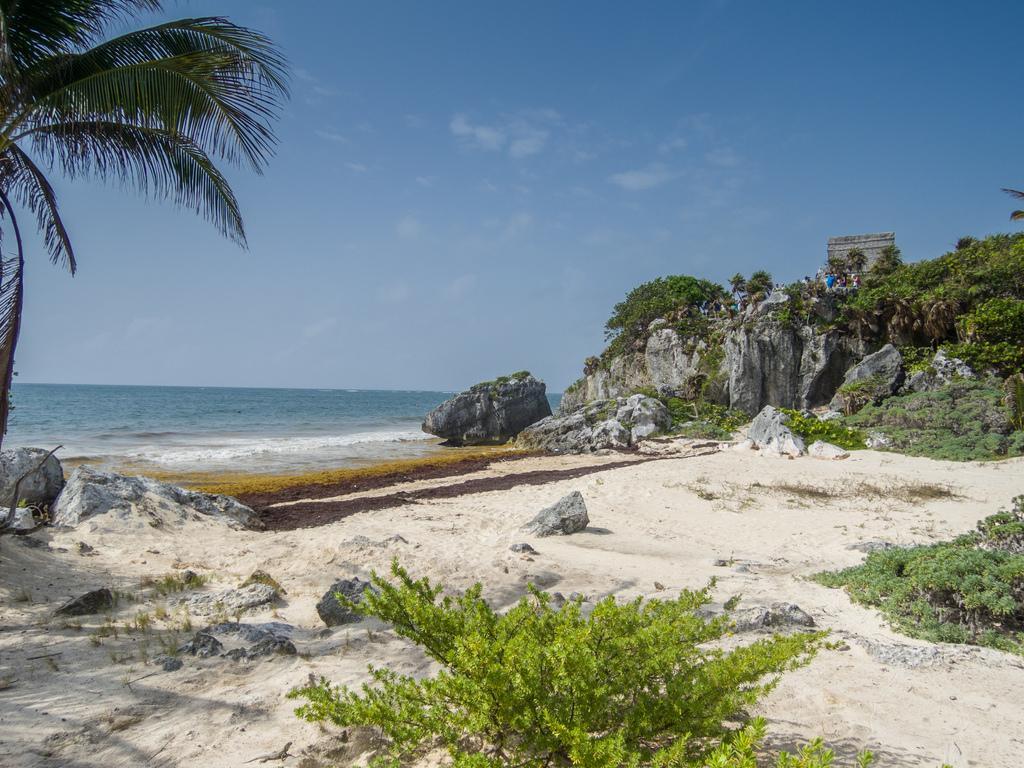Describe this image in one or two sentences. Front side of the image we can see plants and left side of the image we can see tree leaves. Background we can see rocks,water,plants and sky. 